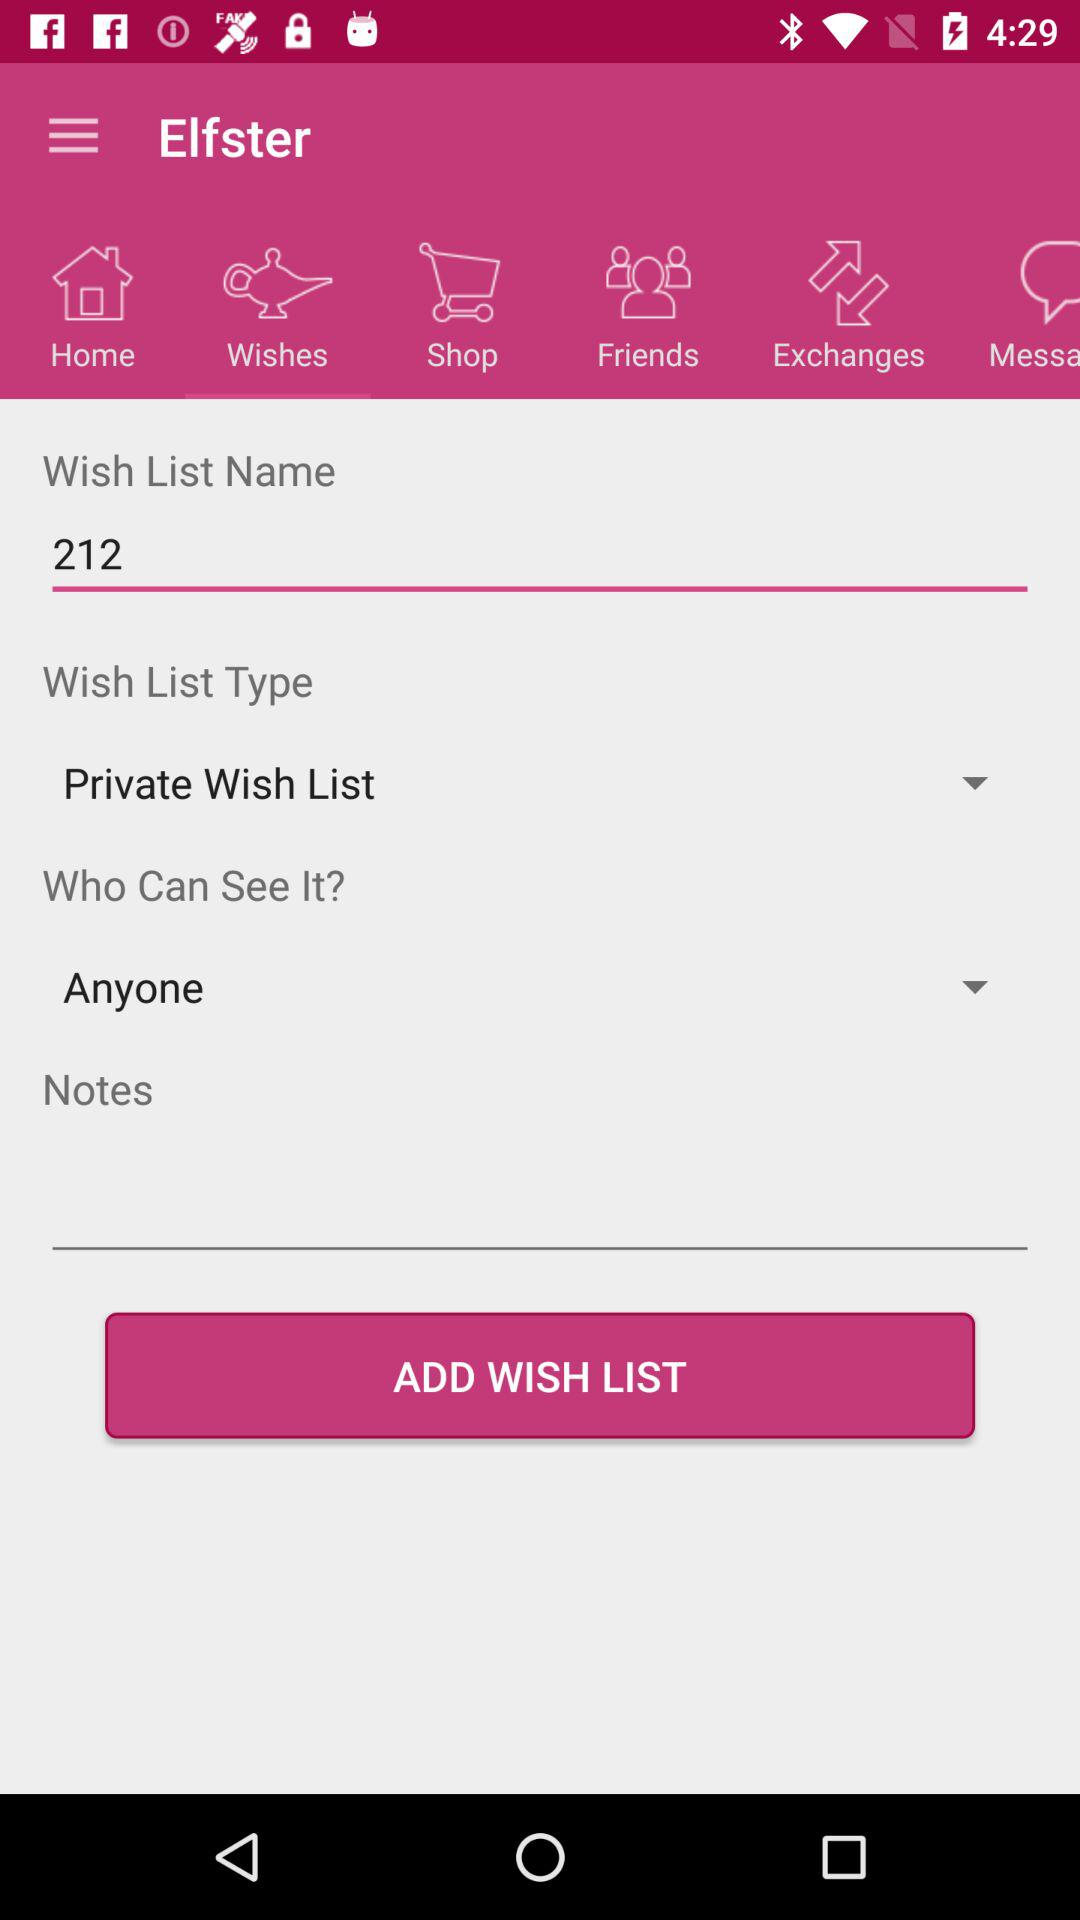What is the wish list type? The wish list type is "Private Wish List". 